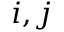<formula> <loc_0><loc_0><loc_500><loc_500>i , j</formula> 